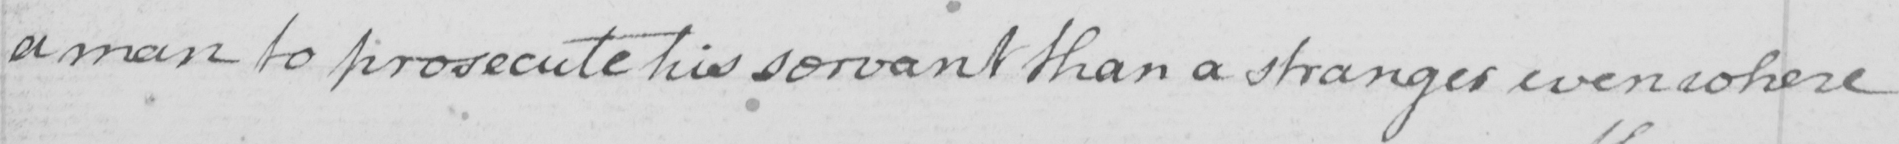Transcribe the text shown in this historical manuscript line. a man to prosecute his servant than a stranger even where 